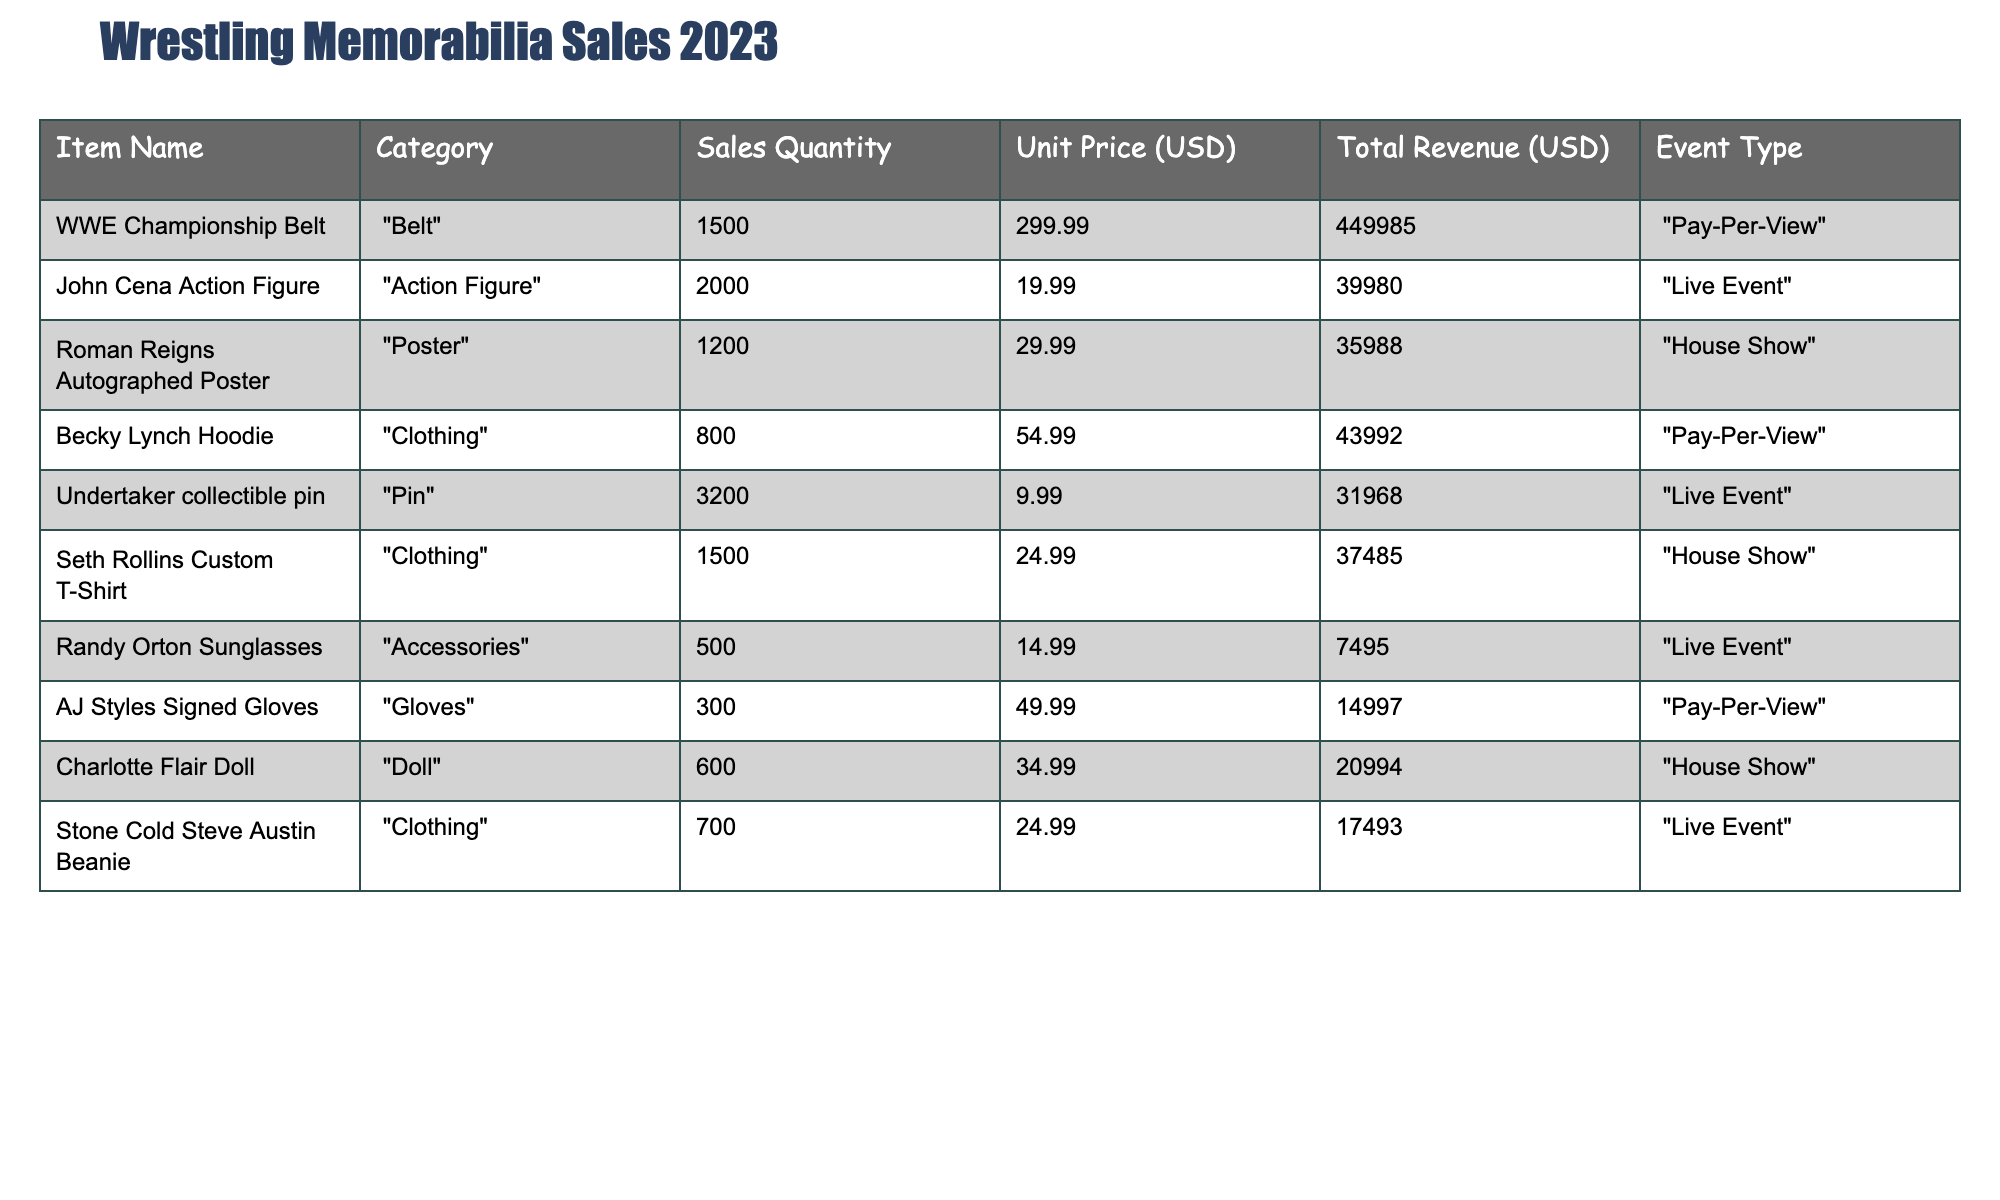What is the total revenue from selling "WWE Championship Belt"? The total revenue for "WWE Championship Belt" is listed directly in the table as $449,985.
Answer: $449,985 How many units of "John Cena Action Figure" were sold? The units sold for "John Cena Action Figure" are stated in the table as 2,000.
Answer: 2,000 Which item generated the highest total revenue? By comparing the total revenue values in the table, "WWE Championship Belt" has the highest total revenue of $449,985.
Answer: WWE Championship Belt What is the average unit price of all merchandise sold? The unit prices are $299.99, $19.99, $29.99, $54.99, $9.99, $24.99, $14.99, $49.99, $34.99, and $24.99. Adding them together gives $299.99 + $19.99 + $29.99 + $54.99 + $9.99 + $24.99 + $14.99 + $49.99 + $34.99 + $24.99 = $ 600.00, and dividing by 10 items gives an average of $60.00.
Answer: $60.00 Did "Randy Orton Sunglasses" generate more revenue than "Charlotte Flair Doll"? "Randy Orton Sunglasses" generated $7,495, while "Charlotte Flair Doll" generated $20,994. Since $7,495 is less than $20,994, it is false that "Randy Orton Sunglasses" generated more revenue.
Answer: No What is the difference in sales quantity between "Undertaker collectible pin" and "Becky Lynch Hoodie"? The sales quantity for "Undertaker collectible pin" is 3,200, and for "Becky Lynch Hoodie" it is 800. The difference is calculated by subtracting 800 from 3,200, which equals 2,400.
Answer: 2,400 Which event type had the most total merchandise sales quantity? By summing the sales quantities for each event type in the table: Pay-Per-View: 2,300 (1,500 + 800 + 300), Live Event: 5,000 (2,000 + 3,200 + 500 + 700), and House Show: 2,400 (1,200 + 1,500 + 600). The Live Event category has the highest total with 5,000 units sold.
Answer: Live Event How much total revenue did the "Clothing" category generate? The items in the "Clothing" category are "Becky Lynch Hoodie" ($43,992), "Seth Rollins Custom T-Shirt" ($37,485), and "Stone Cold Steve Austin Beanie" ($17,493). Adding these revenues gives $43,992 + $37,485 + $17,493 = $98,970 total revenue.
Answer: $98,970 Is the total revenue of all items greater than $1,000,000? To find the total revenue, we add all individual total revenues: $449,985 + $39,980 + $35,988 + $43,992 + $31,968 + $37,485 + $7,495 + $14,997 + $20,994 + $17,493 = $758,982. Since this total is less than $1,000,000, the answer is no.
Answer: No Which item sold the least number of units? By looking at the sales quantities in the table, the item with the least units sold is "AJ Styles Signed Gloves" with 300 units.
Answer: AJ Styles Signed Gloves If we combine all revenues from "Live Event" merchandise, what is that total? The revenues from "Live Event" items are as follows: "John Cena Action Figure" ($39,980), "Undertaker collectible pin" ($31,968), "Randy Orton Sunglasses" ($7,495), and "Stone Cold Steve Austin Beanie" ($17,493). Adding these amounts gives $39,980 + $31,968 + $7,495 + $17,493 = $96,936 total revenue for Live Events.
Answer: $96,936 